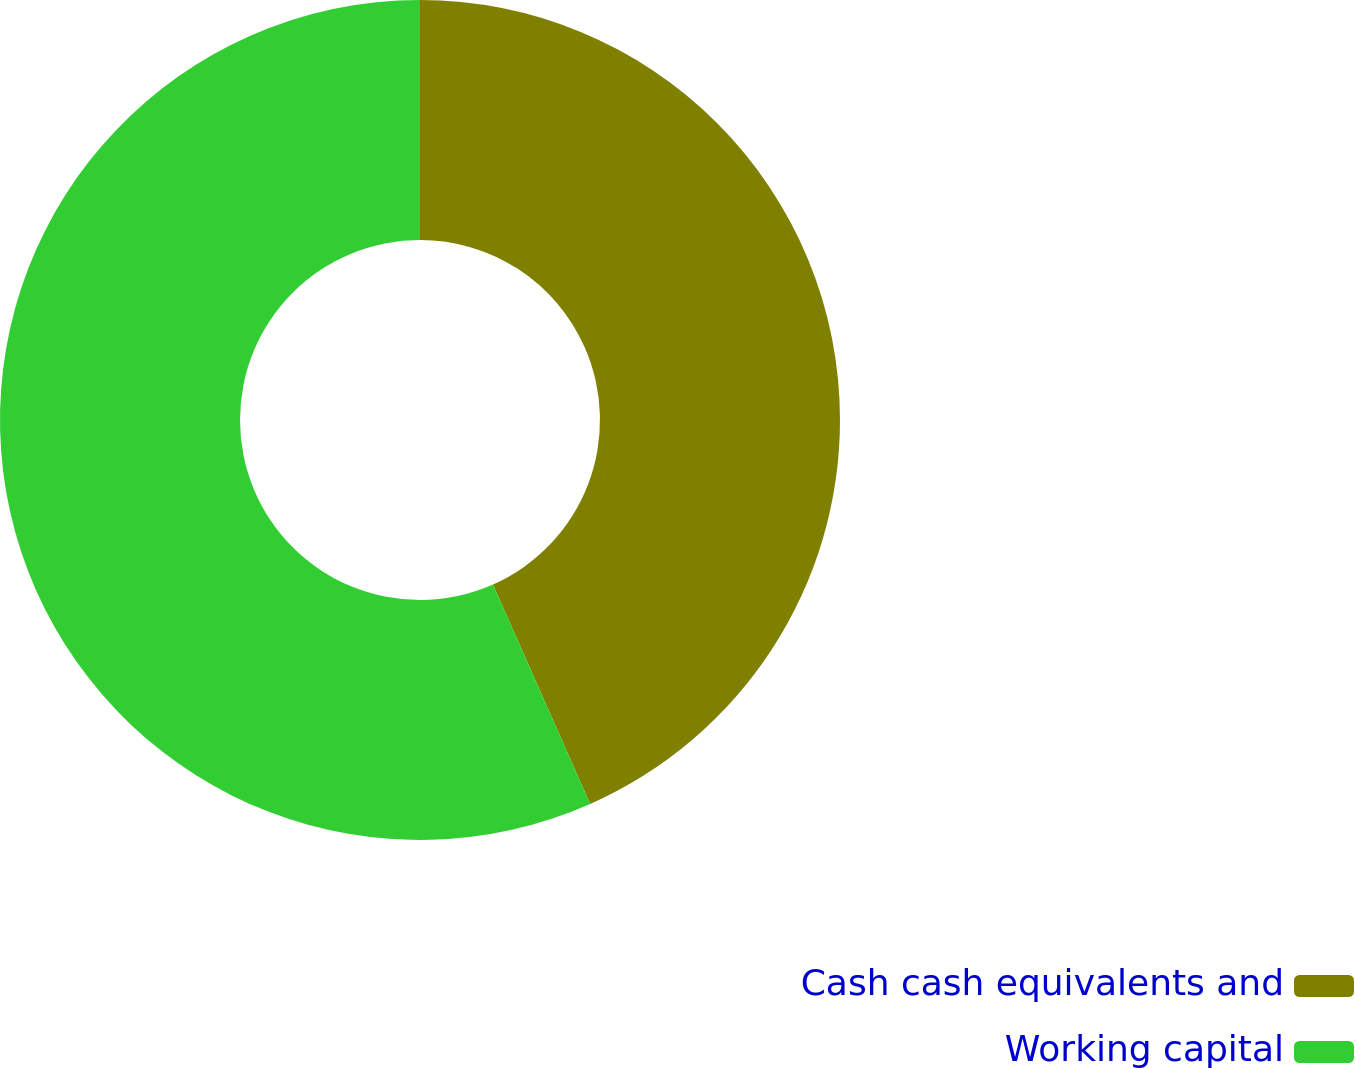Convert chart to OTSL. <chart><loc_0><loc_0><loc_500><loc_500><pie_chart><fcel>Cash cash equivalents and<fcel>Working capital<nl><fcel>43.36%<fcel>56.64%<nl></chart> 